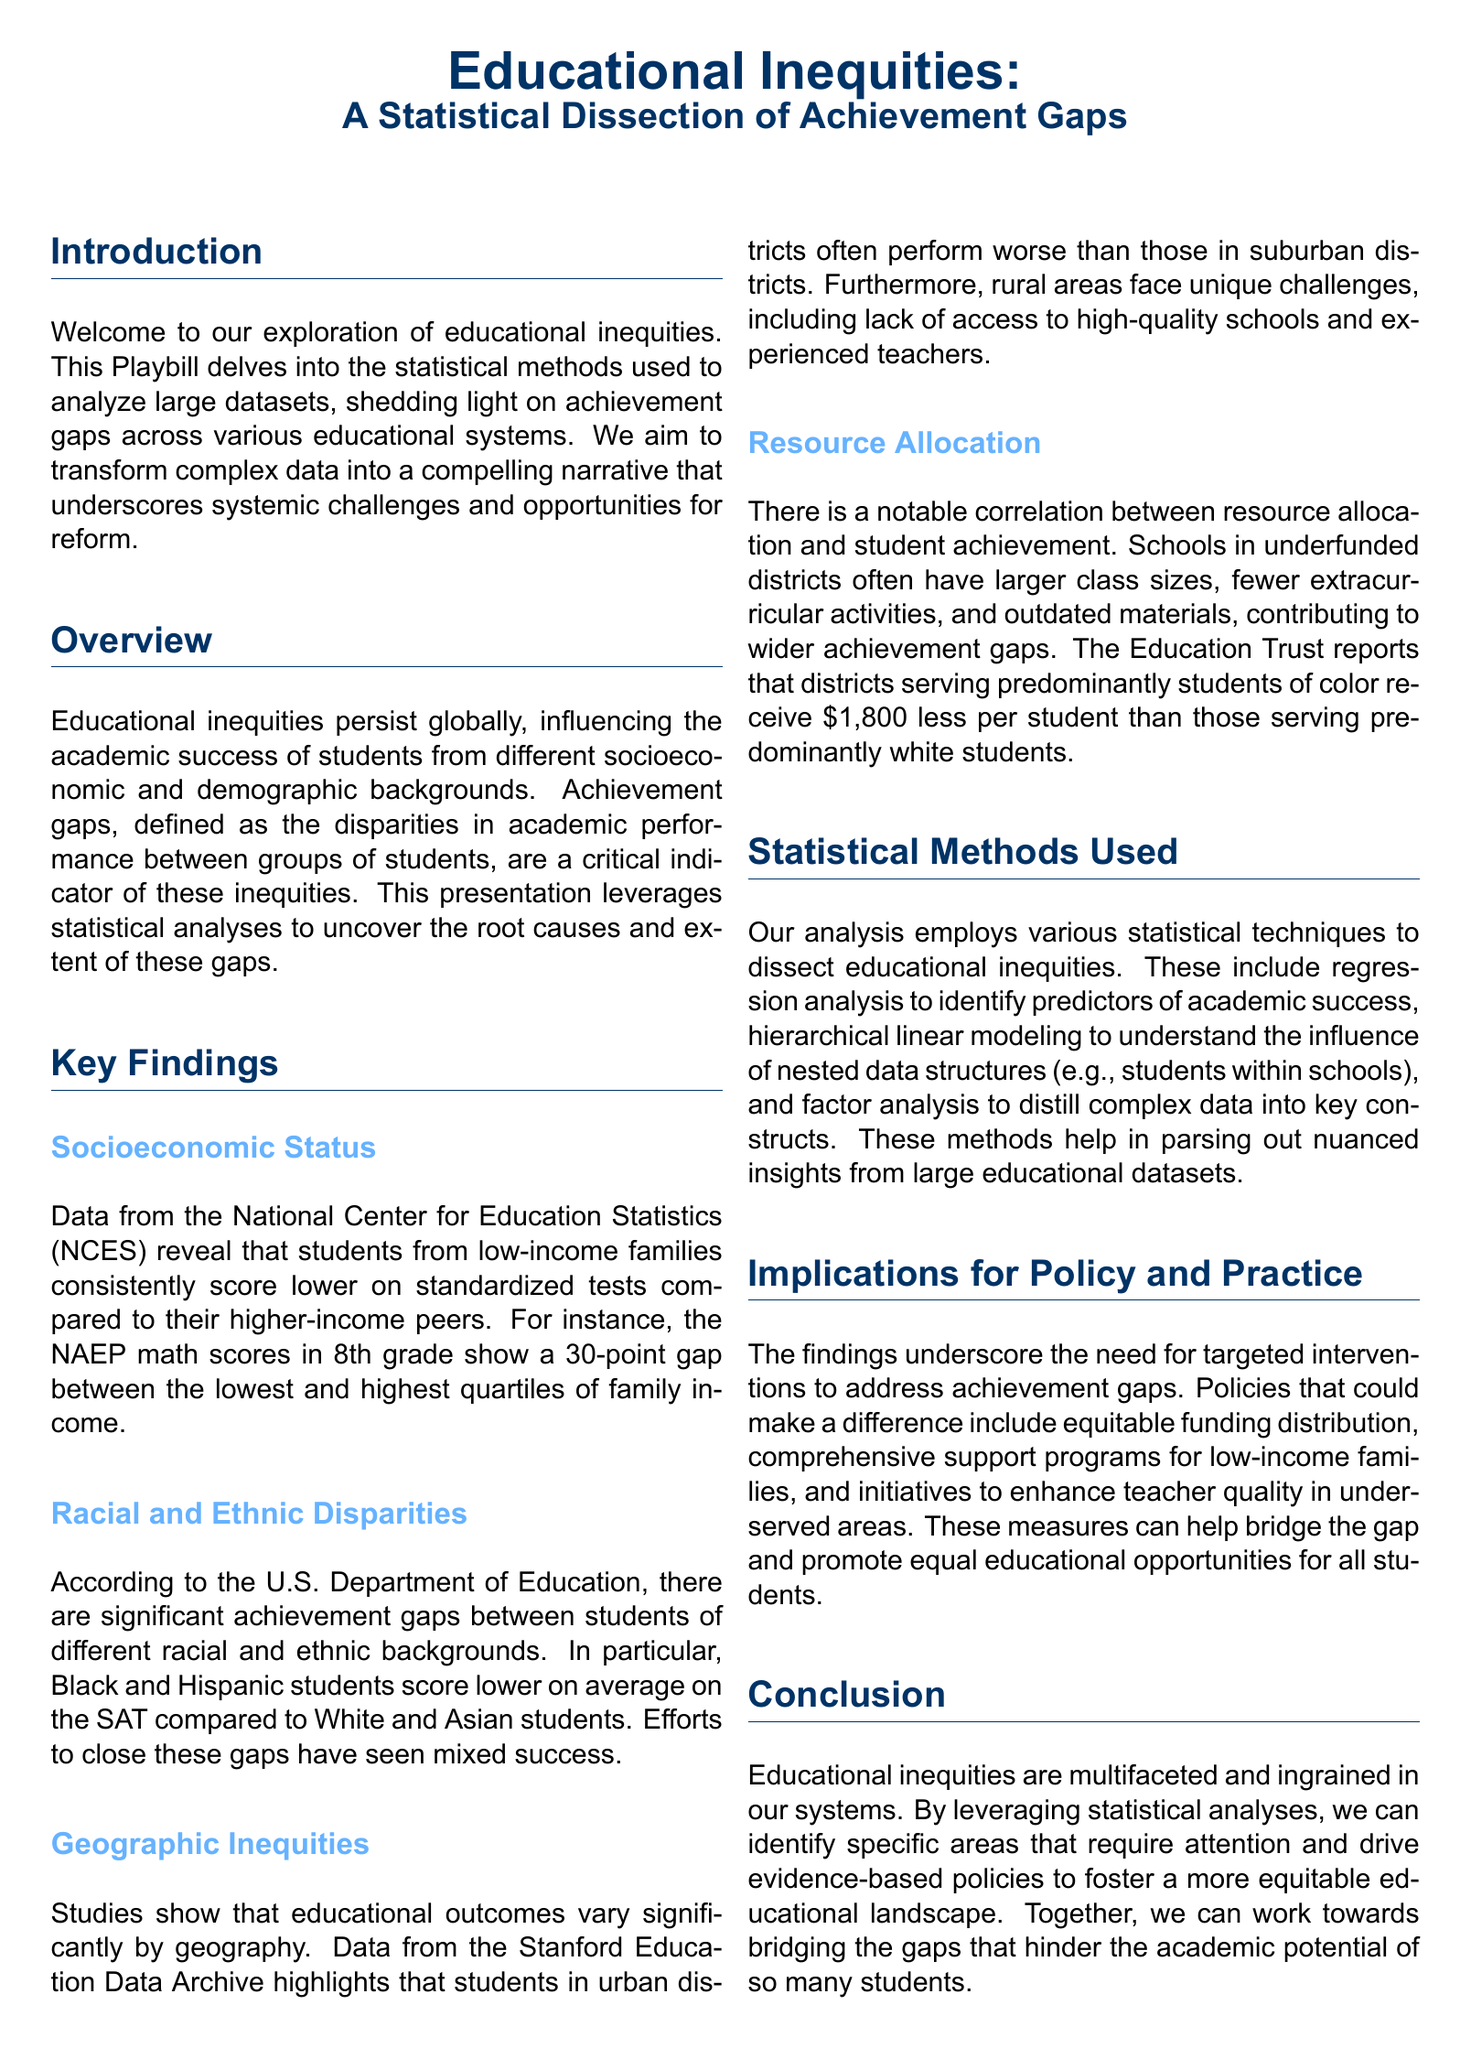What is the main focus of the Playbill? The introduction specifies that the Playbill focuses on educational inequities and achievement gaps through statistical analysis.
Answer: Educational inequities What is the 30-point gap related to? The document states that there is a 30-point gap in NAEP math scores between income quartiles in 8th grade.
Answer: NAEP math scores What demographic groups are identified as having significant achievement gaps? The document mentions that Black and Hispanic students score lower compared to White and Asian students.
Answer: Black and Hispanic students What type of statistical method is used to identify predictors of academic success? The document indicates that regression analysis is employed to identify predictors of academic success.
Answer: Regression analysis According to the Playbill, how much less do predominantly students of color districts receive per student? The key findings state that these districts receive $1,800 less per student than predominantly white districts.
Answer: $1,800 What regions are highlighted as performing worse in educational outcomes? The findings emphasize that urban districts often perform worse than suburban districts.
Answer: Urban districts What is recommended to address achievement gaps in the document? The implications section suggests equitable funding distribution as a key recommendation for addressing achievement gaps.
Answer: Equitable funding distribution What kind of analysis is used to understand nested data structures? The document states that hierarchical linear modeling is utilized to understand nested data structures.
Answer: Hierarchical linear modeling Where can further reading be found according to the Playbill? The conclusion section invites readers to visit the website for further reading and in-depth analysis.
Answer: website 